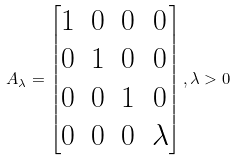Convert formula to latex. <formula><loc_0><loc_0><loc_500><loc_500>A _ { \lambda } = \begin{bmatrix} 1 & 0 & 0 & 0 \\ 0 & 1 & 0 & 0 \\ 0 & 0 & 1 & 0 \\ 0 & 0 & 0 & \lambda \end{bmatrix} , \lambda > 0</formula> 